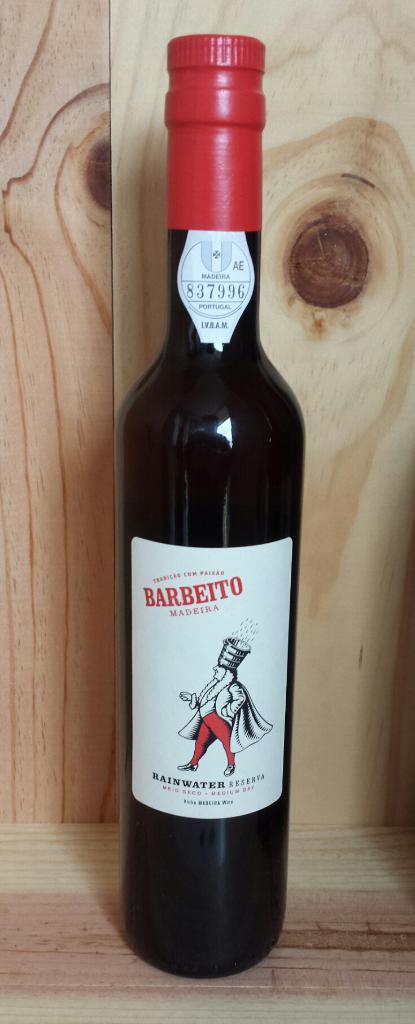What does it say on the bottom of the label?
Your answer should be very brief. Rainwater. 